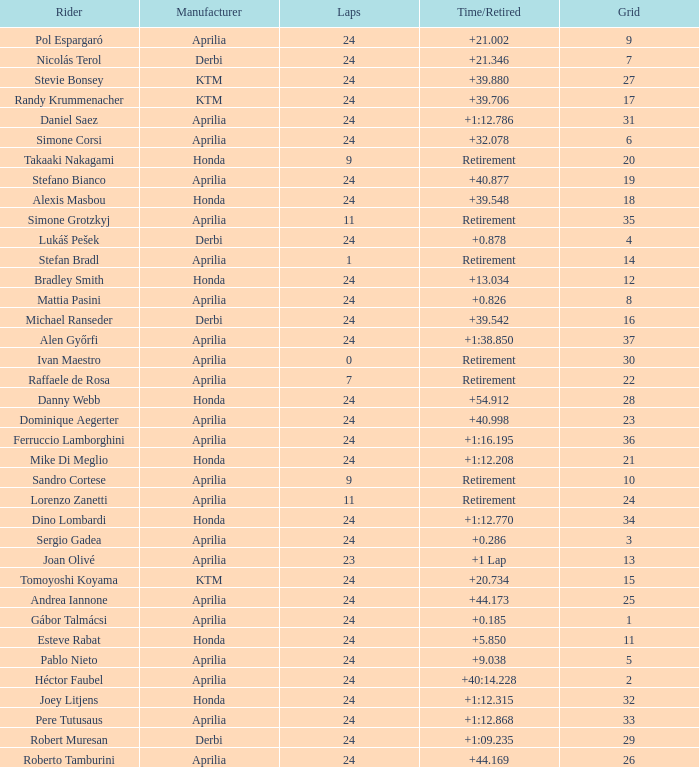How many grids correspond to more than 24 laps? None. 